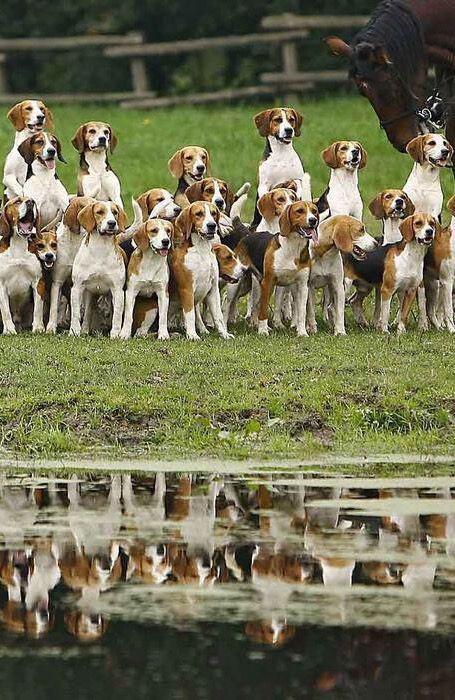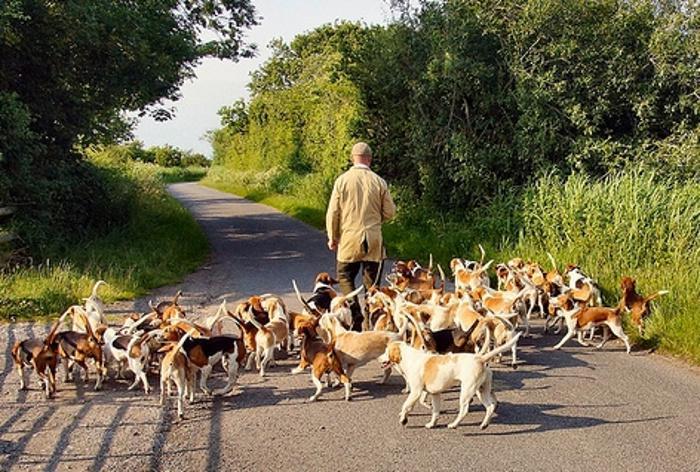The first image is the image on the left, the second image is the image on the right. Considering the images on both sides, is "One image shows a man in a hat leading a pack of dogs down a paved country lane." valid? Answer yes or no. Yes. 